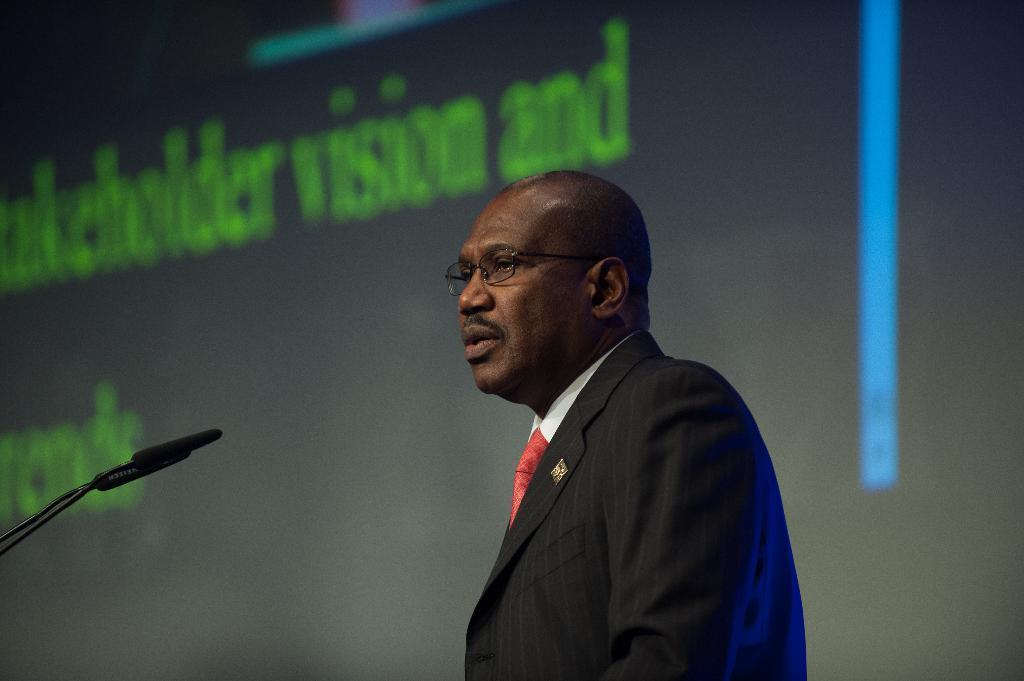Could you give a brief overview of what you see in this image? In the image there is a bald headed man in black suit talking on mic and behind there is a screen. 